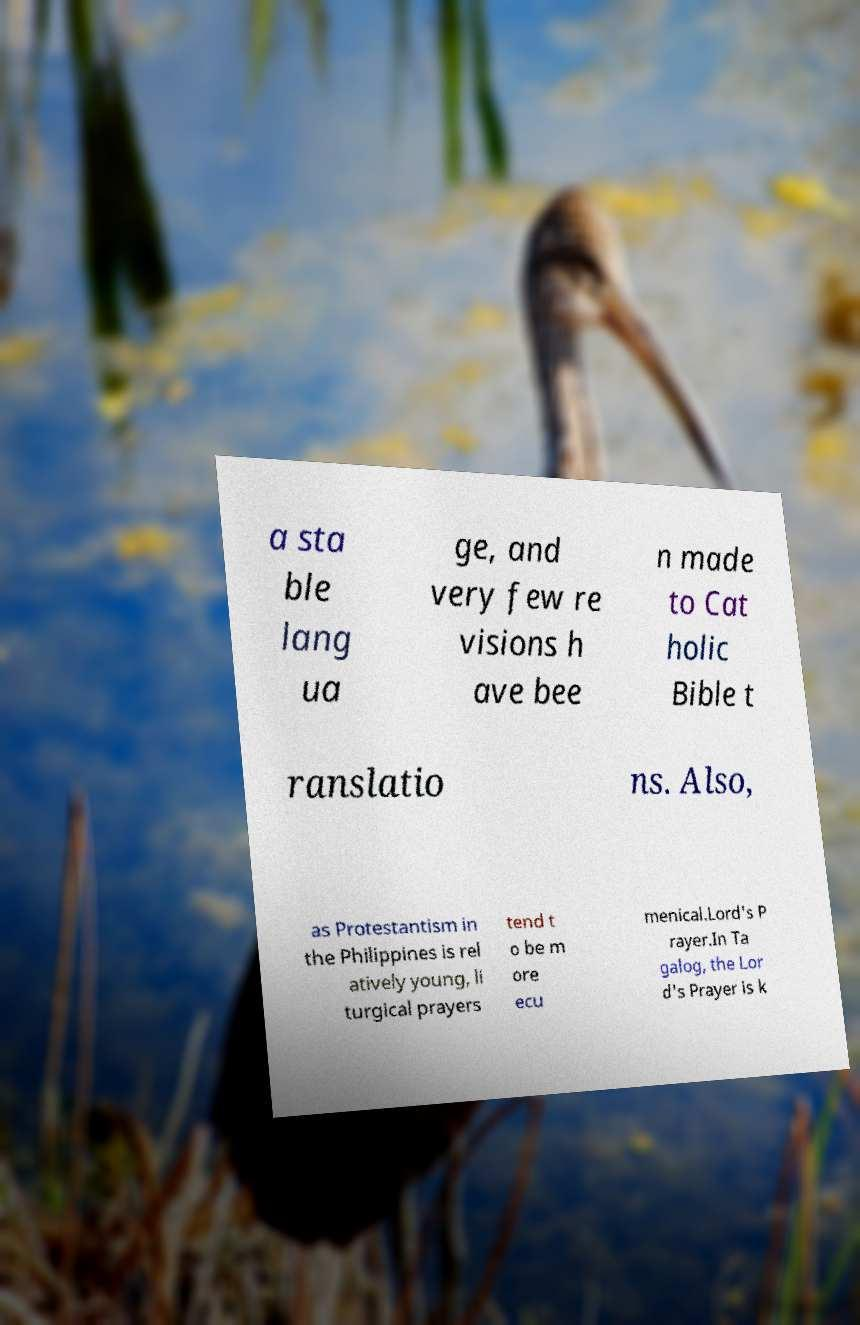Please read and relay the text visible in this image. What does it say? a sta ble lang ua ge, and very few re visions h ave bee n made to Cat holic Bible t ranslatio ns. Also, as Protestantism in the Philippines is rel atively young, li turgical prayers tend t o be m ore ecu menical.Lord's P rayer.In Ta galog, the Lor d's Prayer is k 